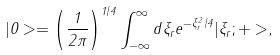Convert formula to latex. <formula><loc_0><loc_0><loc_500><loc_500>| 0 > = \left ( \frac { 1 } { 2 \pi } \right ) ^ { 1 / 4 } \int _ { - \infty } ^ { \infty } d \xi _ { r } e ^ { - \xi _ { r } ^ { 2 } / 4 } | \xi _ { r } ; + > ,</formula> 